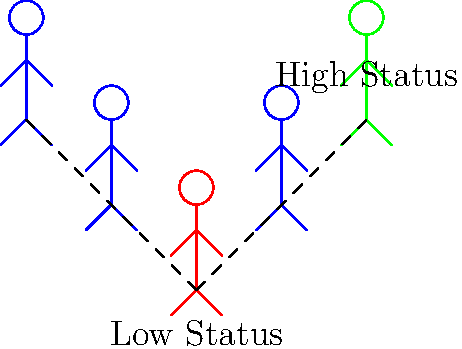In the diagram, stick figures are arranged in a hierarchy representing different social statuses. The red figure at the bottom represents a low-status individual, while the green figure at the top represents a high-status individual. Based on research in social psychology, how would you expect the likelihood of conformity to differ between the low-status (red) and high-status (green) individuals? To answer this question, we need to consider the relationship between social status and conformity:

1. Social status: In the diagram, the red figure at the bottom represents low status, while the green figure at the top represents high status.

2. Conformity and social influence: Conformity refers to changing one's behavior or beliefs to match those of others in a group.

3. Research findings:
   a. Low-status individuals tend to conform more because:
      - They may feel pressure to fit in and gain acceptance.
      - They often lack confidence in their own judgments.
      - They may view high-status individuals as more knowledgeable or powerful.

   b. High-status individuals tend to conform less because:
      - They often have more confidence in their own judgments.
      - They may feel less pressure to fit in, as they already have a secure position.
      - They may be more likely to influence others rather than be influenced.

4. Exceptions: It's important to note that this is a general trend, and individual differences can affect conformity regardless of status.

5. Conclusion: Based on these factors, we would expect the low-status (red) individual to show a higher likelihood of conformity compared to the high-status (green) individual.
Answer: Low-status individuals are more likely to conform than high-status individuals. 